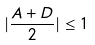Convert formula to latex. <formula><loc_0><loc_0><loc_500><loc_500>| \frac { A + D } { 2 } | \leq 1</formula> 